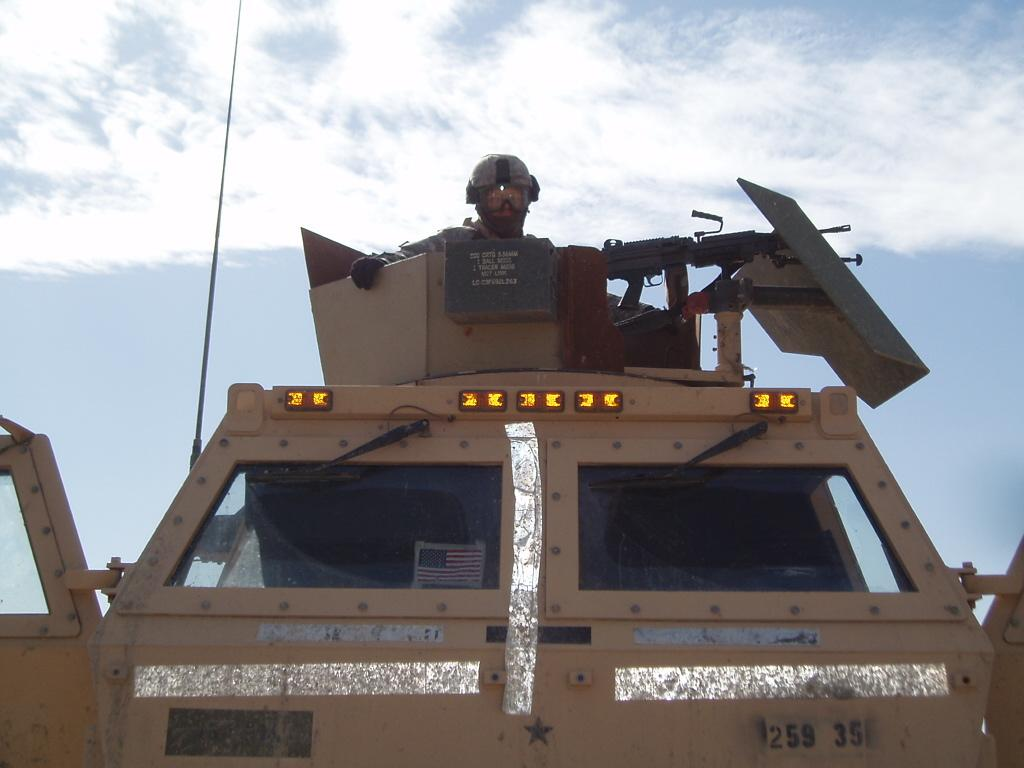What type of person is in the vehicle in the image? There is a soldier in the vehicle in the image. What type of weapon can be seen in the image? There is a gun visible in the image. What is visible at the top of the image? The sky is visible at the top of the image. What type of nail is being used to hold the gold in the image? There is no nail or gold present in the image. What type of farm can be seen in the background of the image? There is no farm visible in the image. 